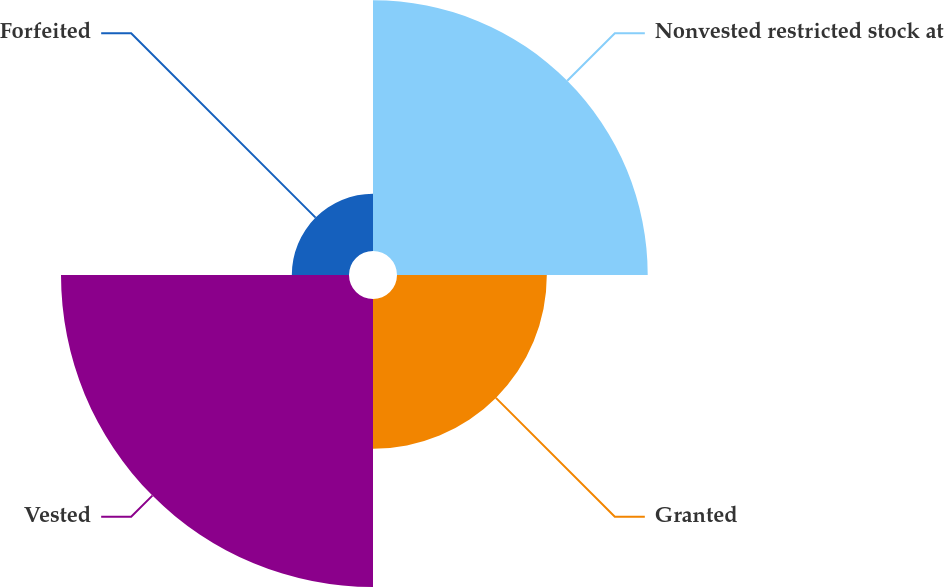Convert chart. <chart><loc_0><loc_0><loc_500><loc_500><pie_chart><fcel>Nonvested restricted stock at<fcel>Granted<fcel>Vested<fcel>Forfeited<nl><fcel>33.62%<fcel>20.09%<fcel>38.62%<fcel>7.67%<nl></chart> 